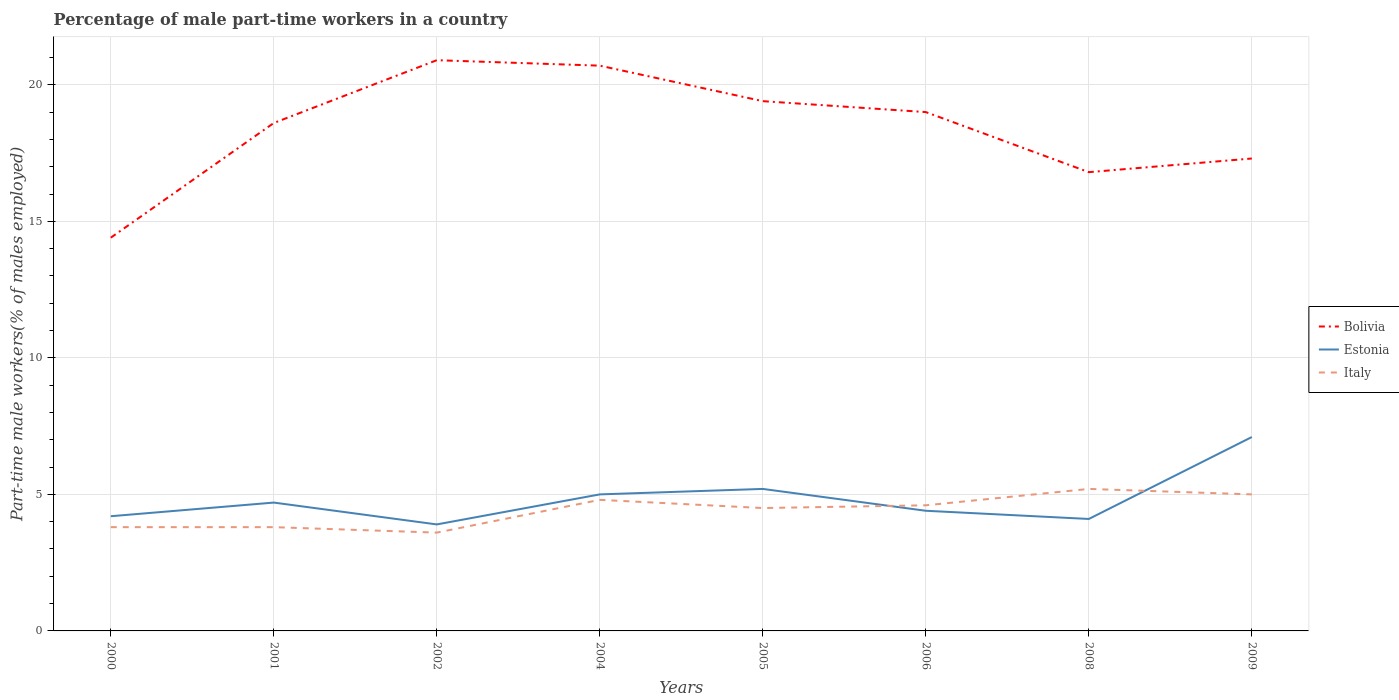How many different coloured lines are there?
Offer a very short reply. 3. Does the line corresponding to Italy intersect with the line corresponding to Bolivia?
Your answer should be very brief. No. Across all years, what is the maximum percentage of male part-time workers in Estonia?
Ensure brevity in your answer.  3.9. In which year was the percentage of male part-time workers in Italy maximum?
Give a very brief answer. 2002. What is the total percentage of male part-time workers in Estonia in the graph?
Keep it short and to the point. 0.6. What is the difference between the highest and the second highest percentage of male part-time workers in Italy?
Your response must be concise. 1.6. What is the difference between the highest and the lowest percentage of male part-time workers in Estonia?
Your response must be concise. 3. How many lines are there?
Offer a terse response. 3. How many years are there in the graph?
Your answer should be compact. 8. What is the difference between two consecutive major ticks on the Y-axis?
Provide a succinct answer. 5. Are the values on the major ticks of Y-axis written in scientific E-notation?
Offer a very short reply. No. Does the graph contain any zero values?
Provide a short and direct response. No. Where does the legend appear in the graph?
Make the answer very short. Center right. How many legend labels are there?
Offer a very short reply. 3. How are the legend labels stacked?
Offer a very short reply. Vertical. What is the title of the graph?
Make the answer very short. Percentage of male part-time workers in a country. What is the label or title of the X-axis?
Your answer should be very brief. Years. What is the label or title of the Y-axis?
Provide a short and direct response. Part-time male workers(% of males employed). What is the Part-time male workers(% of males employed) in Bolivia in 2000?
Give a very brief answer. 14.4. What is the Part-time male workers(% of males employed) in Estonia in 2000?
Provide a succinct answer. 4.2. What is the Part-time male workers(% of males employed) in Italy in 2000?
Give a very brief answer. 3.8. What is the Part-time male workers(% of males employed) of Bolivia in 2001?
Offer a terse response. 18.6. What is the Part-time male workers(% of males employed) in Estonia in 2001?
Your answer should be very brief. 4.7. What is the Part-time male workers(% of males employed) in Italy in 2001?
Make the answer very short. 3.8. What is the Part-time male workers(% of males employed) in Bolivia in 2002?
Make the answer very short. 20.9. What is the Part-time male workers(% of males employed) of Estonia in 2002?
Give a very brief answer. 3.9. What is the Part-time male workers(% of males employed) in Italy in 2002?
Make the answer very short. 3.6. What is the Part-time male workers(% of males employed) of Bolivia in 2004?
Offer a terse response. 20.7. What is the Part-time male workers(% of males employed) in Italy in 2004?
Your response must be concise. 4.8. What is the Part-time male workers(% of males employed) of Bolivia in 2005?
Offer a terse response. 19.4. What is the Part-time male workers(% of males employed) of Estonia in 2005?
Your response must be concise. 5.2. What is the Part-time male workers(% of males employed) in Italy in 2005?
Provide a short and direct response. 4.5. What is the Part-time male workers(% of males employed) in Estonia in 2006?
Give a very brief answer. 4.4. What is the Part-time male workers(% of males employed) in Italy in 2006?
Your answer should be compact. 4.6. What is the Part-time male workers(% of males employed) of Bolivia in 2008?
Give a very brief answer. 16.8. What is the Part-time male workers(% of males employed) of Estonia in 2008?
Your response must be concise. 4.1. What is the Part-time male workers(% of males employed) in Italy in 2008?
Keep it short and to the point. 5.2. What is the Part-time male workers(% of males employed) of Bolivia in 2009?
Keep it short and to the point. 17.3. What is the Part-time male workers(% of males employed) in Estonia in 2009?
Offer a very short reply. 7.1. What is the Part-time male workers(% of males employed) of Italy in 2009?
Your answer should be very brief. 5. Across all years, what is the maximum Part-time male workers(% of males employed) in Bolivia?
Provide a short and direct response. 20.9. Across all years, what is the maximum Part-time male workers(% of males employed) of Estonia?
Offer a terse response. 7.1. Across all years, what is the maximum Part-time male workers(% of males employed) of Italy?
Provide a succinct answer. 5.2. Across all years, what is the minimum Part-time male workers(% of males employed) of Bolivia?
Your response must be concise. 14.4. Across all years, what is the minimum Part-time male workers(% of males employed) in Estonia?
Your answer should be compact. 3.9. Across all years, what is the minimum Part-time male workers(% of males employed) in Italy?
Your answer should be very brief. 3.6. What is the total Part-time male workers(% of males employed) in Bolivia in the graph?
Ensure brevity in your answer.  147.1. What is the total Part-time male workers(% of males employed) of Estonia in the graph?
Give a very brief answer. 38.6. What is the total Part-time male workers(% of males employed) in Italy in the graph?
Keep it short and to the point. 35.3. What is the difference between the Part-time male workers(% of males employed) of Bolivia in 2000 and that in 2001?
Keep it short and to the point. -4.2. What is the difference between the Part-time male workers(% of males employed) in Estonia in 2000 and that in 2001?
Provide a short and direct response. -0.5. What is the difference between the Part-time male workers(% of males employed) in Italy in 2000 and that in 2001?
Your response must be concise. 0. What is the difference between the Part-time male workers(% of males employed) in Estonia in 2000 and that in 2002?
Offer a terse response. 0.3. What is the difference between the Part-time male workers(% of males employed) in Italy in 2000 and that in 2002?
Offer a very short reply. 0.2. What is the difference between the Part-time male workers(% of males employed) in Bolivia in 2000 and that in 2004?
Offer a very short reply. -6.3. What is the difference between the Part-time male workers(% of males employed) in Estonia in 2000 and that in 2004?
Ensure brevity in your answer.  -0.8. What is the difference between the Part-time male workers(% of males employed) in Italy in 2000 and that in 2004?
Offer a terse response. -1. What is the difference between the Part-time male workers(% of males employed) of Bolivia in 2000 and that in 2005?
Make the answer very short. -5. What is the difference between the Part-time male workers(% of males employed) in Bolivia in 2000 and that in 2006?
Give a very brief answer. -4.6. What is the difference between the Part-time male workers(% of males employed) in Estonia in 2000 and that in 2006?
Offer a terse response. -0.2. What is the difference between the Part-time male workers(% of males employed) of Italy in 2000 and that in 2006?
Your answer should be compact. -0.8. What is the difference between the Part-time male workers(% of males employed) of Estonia in 2000 and that in 2008?
Your answer should be very brief. 0.1. What is the difference between the Part-time male workers(% of males employed) of Italy in 2000 and that in 2008?
Keep it short and to the point. -1.4. What is the difference between the Part-time male workers(% of males employed) in Italy in 2000 and that in 2009?
Offer a very short reply. -1.2. What is the difference between the Part-time male workers(% of males employed) of Estonia in 2001 and that in 2002?
Make the answer very short. 0.8. What is the difference between the Part-time male workers(% of males employed) in Bolivia in 2001 and that in 2004?
Make the answer very short. -2.1. What is the difference between the Part-time male workers(% of males employed) in Estonia in 2001 and that in 2005?
Your response must be concise. -0.5. What is the difference between the Part-time male workers(% of males employed) of Italy in 2001 and that in 2005?
Ensure brevity in your answer.  -0.7. What is the difference between the Part-time male workers(% of males employed) in Estonia in 2001 and that in 2006?
Keep it short and to the point. 0.3. What is the difference between the Part-time male workers(% of males employed) of Italy in 2001 and that in 2006?
Offer a terse response. -0.8. What is the difference between the Part-time male workers(% of males employed) of Estonia in 2001 and that in 2008?
Keep it short and to the point. 0.6. What is the difference between the Part-time male workers(% of males employed) in Estonia in 2002 and that in 2004?
Ensure brevity in your answer.  -1.1. What is the difference between the Part-time male workers(% of males employed) in Italy in 2002 and that in 2004?
Provide a succinct answer. -1.2. What is the difference between the Part-time male workers(% of males employed) in Estonia in 2002 and that in 2005?
Offer a very short reply. -1.3. What is the difference between the Part-time male workers(% of males employed) of Italy in 2002 and that in 2005?
Your response must be concise. -0.9. What is the difference between the Part-time male workers(% of males employed) in Italy in 2002 and that in 2006?
Keep it short and to the point. -1. What is the difference between the Part-time male workers(% of males employed) of Bolivia in 2002 and that in 2008?
Give a very brief answer. 4.1. What is the difference between the Part-time male workers(% of males employed) of Estonia in 2002 and that in 2008?
Provide a short and direct response. -0.2. What is the difference between the Part-time male workers(% of males employed) of Italy in 2002 and that in 2008?
Provide a short and direct response. -1.6. What is the difference between the Part-time male workers(% of males employed) in Estonia in 2002 and that in 2009?
Your response must be concise. -3.2. What is the difference between the Part-time male workers(% of males employed) in Estonia in 2004 and that in 2005?
Your response must be concise. -0.2. What is the difference between the Part-time male workers(% of males employed) in Bolivia in 2004 and that in 2006?
Make the answer very short. 1.7. What is the difference between the Part-time male workers(% of males employed) of Estonia in 2004 and that in 2009?
Offer a terse response. -2.1. What is the difference between the Part-time male workers(% of males employed) in Estonia in 2005 and that in 2006?
Ensure brevity in your answer.  0.8. What is the difference between the Part-time male workers(% of males employed) in Italy in 2005 and that in 2006?
Give a very brief answer. -0.1. What is the difference between the Part-time male workers(% of males employed) of Italy in 2005 and that in 2009?
Offer a terse response. -0.5. What is the difference between the Part-time male workers(% of males employed) in Estonia in 2006 and that in 2008?
Your response must be concise. 0.3. What is the difference between the Part-time male workers(% of males employed) of Italy in 2006 and that in 2008?
Your response must be concise. -0.6. What is the difference between the Part-time male workers(% of males employed) of Bolivia in 2006 and that in 2009?
Offer a very short reply. 1.7. What is the difference between the Part-time male workers(% of males employed) of Italy in 2006 and that in 2009?
Provide a short and direct response. -0.4. What is the difference between the Part-time male workers(% of males employed) in Estonia in 2008 and that in 2009?
Your answer should be very brief. -3. What is the difference between the Part-time male workers(% of males employed) of Bolivia in 2000 and the Part-time male workers(% of males employed) of Estonia in 2001?
Provide a succinct answer. 9.7. What is the difference between the Part-time male workers(% of males employed) in Estonia in 2000 and the Part-time male workers(% of males employed) in Italy in 2001?
Make the answer very short. 0.4. What is the difference between the Part-time male workers(% of males employed) in Bolivia in 2000 and the Part-time male workers(% of males employed) in Estonia in 2002?
Offer a terse response. 10.5. What is the difference between the Part-time male workers(% of males employed) in Bolivia in 2000 and the Part-time male workers(% of males employed) in Italy in 2002?
Provide a short and direct response. 10.8. What is the difference between the Part-time male workers(% of males employed) of Estonia in 2000 and the Part-time male workers(% of males employed) of Italy in 2002?
Make the answer very short. 0.6. What is the difference between the Part-time male workers(% of males employed) in Bolivia in 2000 and the Part-time male workers(% of males employed) in Estonia in 2008?
Your response must be concise. 10.3. What is the difference between the Part-time male workers(% of males employed) of Estonia in 2000 and the Part-time male workers(% of males employed) of Italy in 2008?
Your answer should be very brief. -1. What is the difference between the Part-time male workers(% of males employed) in Bolivia in 2001 and the Part-time male workers(% of males employed) in Estonia in 2002?
Give a very brief answer. 14.7. What is the difference between the Part-time male workers(% of males employed) of Estonia in 2001 and the Part-time male workers(% of males employed) of Italy in 2002?
Ensure brevity in your answer.  1.1. What is the difference between the Part-time male workers(% of males employed) of Bolivia in 2001 and the Part-time male workers(% of males employed) of Estonia in 2004?
Your response must be concise. 13.6. What is the difference between the Part-time male workers(% of males employed) of Estonia in 2001 and the Part-time male workers(% of males employed) of Italy in 2004?
Your answer should be very brief. -0.1. What is the difference between the Part-time male workers(% of males employed) of Bolivia in 2001 and the Part-time male workers(% of males employed) of Estonia in 2005?
Your answer should be compact. 13.4. What is the difference between the Part-time male workers(% of males employed) of Bolivia in 2001 and the Part-time male workers(% of males employed) of Italy in 2005?
Keep it short and to the point. 14.1. What is the difference between the Part-time male workers(% of males employed) in Estonia in 2001 and the Part-time male workers(% of males employed) in Italy in 2005?
Your answer should be compact. 0.2. What is the difference between the Part-time male workers(% of males employed) of Estonia in 2001 and the Part-time male workers(% of males employed) of Italy in 2006?
Give a very brief answer. 0.1. What is the difference between the Part-time male workers(% of males employed) in Bolivia in 2001 and the Part-time male workers(% of males employed) in Italy in 2008?
Your response must be concise. 13.4. What is the difference between the Part-time male workers(% of males employed) of Estonia in 2001 and the Part-time male workers(% of males employed) of Italy in 2008?
Give a very brief answer. -0.5. What is the difference between the Part-time male workers(% of males employed) in Bolivia in 2002 and the Part-time male workers(% of males employed) in Estonia in 2004?
Your answer should be very brief. 15.9. What is the difference between the Part-time male workers(% of males employed) of Estonia in 2002 and the Part-time male workers(% of males employed) of Italy in 2005?
Offer a very short reply. -0.6. What is the difference between the Part-time male workers(% of males employed) in Bolivia in 2002 and the Part-time male workers(% of males employed) in Italy in 2006?
Offer a very short reply. 16.3. What is the difference between the Part-time male workers(% of males employed) in Estonia in 2002 and the Part-time male workers(% of males employed) in Italy in 2006?
Make the answer very short. -0.7. What is the difference between the Part-time male workers(% of males employed) of Bolivia in 2002 and the Part-time male workers(% of males employed) of Estonia in 2008?
Offer a terse response. 16.8. What is the difference between the Part-time male workers(% of males employed) in Bolivia in 2002 and the Part-time male workers(% of males employed) in Italy in 2008?
Provide a short and direct response. 15.7. What is the difference between the Part-time male workers(% of males employed) of Estonia in 2002 and the Part-time male workers(% of males employed) of Italy in 2008?
Make the answer very short. -1.3. What is the difference between the Part-time male workers(% of males employed) of Bolivia in 2002 and the Part-time male workers(% of males employed) of Estonia in 2009?
Provide a short and direct response. 13.8. What is the difference between the Part-time male workers(% of males employed) in Estonia in 2002 and the Part-time male workers(% of males employed) in Italy in 2009?
Give a very brief answer. -1.1. What is the difference between the Part-time male workers(% of males employed) in Bolivia in 2004 and the Part-time male workers(% of males employed) in Estonia in 2005?
Ensure brevity in your answer.  15.5. What is the difference between the Part-time male workers(% of males employed) of Bolivia in 2004 and the Part-time male workers(% of males employed) of Italy in 2005?
Make the answer very short. 16.2. What is the difference between the Part-time male workers(% of males employed) of Estonia in 2004 and the Part-time male workers(% of males employed) of Italy in 2005?
Give a very brief answer. 0.5. What is the difference between the Part-time male workers(% of males employed) of Bolivia in 2004 and the Part-time male workers(% of males employed) of Estonia in 2006?
Your response must be concise. 16.3. What is the difference between the Part-time male workers(% of males employed) in Bolivia in 2004 and the Part-time male workers(% of males employed) in Italy in 2006?
Your response must be concise. 16.1. What is the difference between the Part-time male workers(% of males employed) of Estonia in 2004 and the Part-time male workers(% of males employed) of Italy in 2008?
Keep it short and to the point. -0.2. What is the difference between the Part-time male workers(% of males employed) of Bolivia in 2004 and the Part-time male workers(% of males employed) of Estonia in 2009?
Make the answer very short. 13.6. What is the difference between the Part-time male workers(% of males employed) in Bolivia in 2004 and the Part-time male workers(% of males employed) in Italy in 2009?
Keep it short and to the point. 15.7. What is the difference between the Part-time male workers(% of males employed) of Bolivia in 2005 and the Part-time male workers(% of males employed) of Italy in 2006?
Your answer should be compact. 14.8. What is the difference between the Part-time male workers(% of males employed) of Bolivia in 2005 and the Part-time male workers(% of males employed) of Estonia in 2008?
Offer a very short reply. 15.3. What is the difference between the Part-time male workers(% of males employed) in Estonia in 2005 and the Part-time male workers(% of males employed) in Italy in 2008?
Ensure brevity in your answer.  0. What is the difference between the Part-time male workers(% of males employed) of Bolivia in 2005 and the Part-time male workers(% of males employed) of Estonia in 2009?
Your response must be concise. 12.3. What is the difference between the Part-time male workers(% of males employed) of Estonia in 2005 and the Part-time male workers(% of males employed) of Italy in 2009?
Ensure brevity in your answer.  0.2. What is the difference between the Part-time male workers(% of males employed) in Bolivia in 2006 and the Part-time male workers(% of males employed) in Estonia in 2008?
Your answer should be very brief. 14.9. What is the difference between the Part-time male workers(% of males employed) in Bolivia in 2006 and the Part-time male workers(% of males employed) in Italy in 2008?
Your answer should be compact. 13.8. What is the difference between the Part-time male workers(% of males employed) of Estonia in 2006 and the Part-time male workers(% of males employed) of Italy in 2008?
Keep it short and to the point. -0.8. What is the difference between the Part-time male workers(% of males employed) of Bolivia in 2006 and the Part-time male workers(% of males employed) of Italy in 2009?
Give a very brief answer. 14. What is the difference between the Part-time male workers(% of males employed) of Estonia in 2006 and the Part-time male workers(% of males employed) of Italy in 2009?
Your answer should be very brief. -0.6. What is the average Part-time male workers(% of males employed) of Bolivia per year?
Offer a terse response. 18.39. What is the average Part-time male workers(% of males employed) of Estonia per year?
Provide a short and direct response. 4.83. What is the average Part-time male workers(% of males employed) of Italy per year?
Your answer should be compact. 4.41. In the year 2000, what is the difference between the Part-time male workers(% of males employed) in Bolivia and Part-time male workers(% of males employed) in Italy?
Give a very brief answer. 10.6. In the year 2001, what is the difference between the Part-time male workers(% of males employed) of Bolivia and Part-time male workers(% of males employed) of Estonia?
Give a very brief answer. 13.9. In the year 2001, what is the difference between the Part-time male workers(% of males employed) of Estonia and Part-time male workers(% of males employed) of Italy?
Your answer should be very brief. 0.9. In the year 2002, what is the difference between the Part-time male workers(% of males employed) in Estonia and Part-time male workers(% of males employed) in Italy?
Provide a succinct answer. 0.3. In the year 2004, what is the difference between the Part-time male workers(% of males employed) in Bolivia and Part-time male workers(% of males employed) in Italy?
Keep it short and to the point. 15.9. In the year 2004, what is the difference between the Part-time male workers(% of males employed) of Estonia and Part-time male workers(% of males employed) of Italy?
Your answer should be very brief. 0.2. In the year 2006, what is the difference between the Part-time male workers(% of males employed) in Bolivia and Part-time male workers(% of males employed) in Estonia?
Provide a short and direct response. 14.6. In the year 2006, what is the difference between the Part-time male workers(% of males employed) in Bolivia and Part-time male workers(% of males employed) in Italy?
Your response must be concise. 14.4. In the year 2008, what is the difference between the Part-time male workers(% of males employed) of Estonia and Part-time male workers(% of males employed) of Italy?
Provide a succinct answer. -1.1. In the year 2009, what is the difference between the Part-time male workers(% of males employed) in Bolivia and Part-time male workers(% of males employed) in Estonia?
Provide a succinct answer. 10.2. In the year 2009, what is the difference between the Part-time male workers(% of males employed) in Bolivia and Part-time male workers(% of males employed) in Italy?
Offer a terse response. 12.3. In the year 2009, what is the difference between the Part-time male workers(% of males employed) in Estonia and Part-time male workers(% of males employed) in Italy?
Your answer should be compact. 2.1. What is the ratio of the Part-time male workers(% of males employed) of Bolivia in 2000 to that in 2001?
Provide a short and direct response. 0.77. What is the ratio of the Part-time male workers(% of males employed) of Estonia in 2000 to that in 2001?
Offer a terse response. 0.89. What is the ratio of the Part-time male workers(% of males employed) of Bolivia in 2000 to that in 2002?
Give a very brief answer. 0.69. What is the ratio of the Part-time male workers(% of males employed) in Italy in 2000 to that in 2002?
Give a very brief answer. 1.06. What is the ratio of the Part-time male workers(% of males employed) in Bolivia in 2000 to that in 2004?
Make the answer very short. 0.7. What is the ratio of the Part-time male workers(% of males employed) of Estonia in 2000 to that in 2004?
Provide a short and direct response. 0.84. What is the ratio of the Part-time male workers(% of males employed) in Italy in 2000 to that in 2004?
Offer a terse response. 0.79. What is the ratio of the Part-time male workers(% of males employed) in Bolivia in 2000 to that in 2005?
Give a very brief answer. 0.74. What is the ratio of the Part-time male workers(% of males employed) in Estonia in 2000 to that in 2005?
Give a very brief answer. 0.81. What is the ratio of the Part-time male workers(% of males employed) of Italy in 2000 to that in 2005?
Give a very brief answer. 0.84. What is the ratio of the Part-time male workers(% of males employed) of Bolivia in 2000 to that in 2006?
Offer a terse response. 0.76. What is the ratio of the Part-time male workers(% of males employed) of Estonia in 2000 to that in 2006?
Ensure brevity in your answer.  0.95. What is the ratio of the Part-time male workers(% of males employed) of Italy in 2000 to that in 2006?
Your answer should be very brief. 0.83. What is the ratio of the Part-time male workers(% of males employed) in Estonia in 2000 to that in 2008?
Ensure brevity in your answer.  1.02. What is the ratio of the Part-time male workers(% of males employed) in Italy in 2000 to that in 2008?
Give a very brief answer. 0.73. What is the ratio of the Part-time male workers(% of males employed) in Bolivia in 2000 to that in 2009?
Your answer should be very brief. 0.83. What is the ratio of the Part-time male workers(% of males employed) of Estonia in 2000 to that in 2009?
Your answer should be very brief. 0.59. What is the ratio of the Part-time male workers(% of males employed) of Italy in 2000 to that in 2009?
Provide a succinct answer. 0.76. What is the ratio of the Part-time male workers(% of males employed) in Bolivia in 2001 to that in 2002?
Make the answer very short. 0.89. What is the ratio of the Part-time male workers(% of males employed) of Estonia in 2001 to that in 2002?
Offer a very short reply. 1.21. What is the ratio of the Part-time male workers(% of males employed) of Italy in 2001 to that in 2002?
Ensure brevity in your answer.  1.06. What is the ratio of the Part-time male workers(% of males employed) in Bolivia in 2001 to that in 2004?
Keep it short and to the point. 0.9. What is the ratio of the Part-time male workers(% of males employed) in Estonia in 2001 to that in 2004?
Offer a very short reply. 0.94. What is the ratio of the Part-time male workers(% of males employed) in Italy in 2001 to that in 2004?
Provide a succinct answer. 0.79. What is the ratio of the Part-time male workers(% of males employed) in Bolivia in 2001 to that in 2005?
Offer a terse response. 0.96. What is the ratio of the Part-time male workers(% of males employed) of Estonia in 2001 to that in 2005?
Ensure brevity in your answer.  0.9. What is the ratio of the Part-time male workers(% of males employed) of Italy in 2001 to that in 2005?
Keep it short and to the point. 0.84. What is the ratio of the Part-time male workers(% of males employed) in Bolivia in 2001 to that in 2006?
Make the answer very short. 0.98. What is the ratio of the Part-time male workers(% of males employed) in Estonia in 2001 to that in 2006?
Ensure brevity in your answer.  1.07. What is the ratio of the Part-time male workers(% of males employed) in Italy in 2001 to that in 2006?
Keep it short and to the point. 0.83. What is the ratio of the Part-time male workers(% of males employed) of Bolivia in 2001 to that in 2008?
Provide a succinct answer. 1.11. What is the ratio of the Part-time male workers(% of males employed) in Estonia in 2001 to that in 2008?
Provide a succinct answer. 1.15. What is the ratio of the Part-time male workers(% of males employed) of Italy in 2001 to that in 2008?
Your response must be concise. 0.73. What is the ratio of the Part-time male workers(% of males employed) of Bolivia in 2001 to that in 2009?
Your response must be concise. 1.08. What is the ratio of the Part-time male workers(% of males employed) of Estonia in 2001 to that in 2009?
Provide a short and direct response. 0.66. What is the ratio of the Part-time male workers(% of males employed) in Italy in 2001 to that in 2009?
Ensure brevity in your answer.  0.76. What is the ratio of the Part-time male workers(% of males employed) in Bolivia in 2002 to that in 2004?
Offer a terse response. 1.01. What is the ratio of the Part-time male workers(% of males employed) in Estonia in 2002 to that in 2004?
Provide a short and direct response. 0.78. What is the ratio of the Part-time male workers(% of males employed) in Italy in 2002 to that in 2004?
Give a very brief answer. 0.75. What is the ratio of the Part-time male workers(% of males employed) in Bolivia in 2002 to that in 2005?
Ensure brevity in your answer.  1.08. What is the ratio of the Part-time male workers(% of males employed) in Estonia in 2002 to that in 2005?
Keep it short and to the point. 0.75. What is the ratio of the Part-time male workers(% of males employed) in Estonia in 2002 to that in 2006?
Ensure brevity in your answer.  0.89. What is the ratio of the Part-time male workers(% of males employed) of Italy in 2002 to that in 2006?
Provide a short and direct response. 0.78. What is the ratio of the Part-time male workers(% of males employed) of Bolivia in 2002 to that in 2008?
Provide a short and direct response. 1.24. What is the ratio of the Part-time male workers(% of males employed) of Estonia in 2002 to that in 2008?
Offer a terse response. 0.95. What is the ratio of the Part-time male workers(% of males employed) of Italy in 2002 to that in 2008?
Provide a succinct answer. 0.69. What is the ratio of the Part-time male workers(% of males employed) of Bolivia in 2002 to that in 2009?
Make the answer very short. 1.21. What is the ratio of the Part-time male workers(% of males employed) in Estonia in 2002 to that in 2009?
Your response must be concise. 0.55. What is the ratio of the Part-time male workers(% of males employed) in Italy in 2002 to that in 2009?
Your response must be concise. 0.72. What is the ratio of the Part-time male workers(% of males employed) in Bolivia in 2004 to that in 2005?
Your answer should be very brief. 1.07. What is the ratio of the Part-time male workers(% of males employed) of Estonia in 2004 to that in 2005?
Offer a terse response. 0.96. What is the ratio of the Part-time male workers(% of males employed) of Italy in 2004 to that in 2005?
Your answer should be very brief. 1.07. What is the ratio of the Part-time male workers(% of males employed) of Bolivia in 2004 to that in 2006?
Give a very brief answer. 1.09. What is the ratio of the Part-time male workers(% of males employed) in Estonia in 2004 to that in 2006?
Ensure brevity in your answer.  1.14. What is the ratio of the Part-time male workers(% of males employed) of Italy in 2004 to that in 2006?
Your answer should be very brief. 1.04. What is the ratio of the Part-time male workers(% of males employed) of Bolivia in 2004 to that in 2008?
Keep it short and to the point. 1.23. What is the ratio of the Part-time male workers(% of males employed) in Estonia in 2004 to that in 2008?
Give a very brief answer. 1.22. What is the ratio of the Part-time male workers(% of males employed) of Bolivia in 2004 to that in 2009?
Your answer should be compact. 1.2. What is the ratio of the Part-time male workers(% of males employed) of Estonia in 2004 to that in 2009?
Your response must be concise. 0.7. What is the ratio of the Part-time male workers(% of males employed) of Italy in 2004 to that in 2009?
Offer a very short reply. 0.96. What is the ratio of the Part-time male workers(% of males employed) of Bolivia in 2005 to that in 2006?
Ensure brevity in your answer.  1.02. What is the ratio of the Part-time male workers(% of males employed) of Estonia in 2005 to that in 2006?
Keep it short and to the point. 1.18. What is the ratio of the Part-time male workers(% of males employed) in Italy in 2005 to that in 2006?
Ensure brevity in your answer.  0.98. What is the ratio of the Part-time male workers(% of males employed) in Bolivia in 2005 to that in 2008?
Keep it short and to the point. 1.15. What is the ratio of the Part-time male workers(% of males employed) of Estonia in 2005 to that in 2008?
Your response must be concise. 1.27. What is the ratio of the Part-time male workers(% of males employed) in Italy in 2005 to that in 2008?
Your response must be concise. 0.87. What is the ratio of the Part-time male workers(% of males employed) of Bolivia in 2005 to that in 2009?
Your answer should be very brief. 1.12. What is the ratio of the Part-time male workers(% of males employed) in Estonia in 2005 to that in 2009?
Keep it short and to the point. 0.73. What is the ratio of the Part-time male workers(% of males employed) in Bolivia in 2006 to that in 2008?
Keep it short and to the point. 1.13. What is the ratio of the Part-time male workers(% of males employed) of Estonia in 2006 to that in 2008?
Keep it short and to the point. 1.07. What is the ratio of the Part-time male workers(% of males employed) of Italy in 2006 to that in 2008?
Your response must be concise. 0.88. What is the ratio of the Part-time male workers(% of males employed) in Bolivia in 2006 to that in 2009?
Keep it short and to the point. 1.1. What is the ratio of the Part-time male workers(% of males employed) of Estonia in 2006 to that in 2009?
Give a very brief answer. 0.62. What is the ratio of the Part-time male workers(% of males employed) of Bolivia in 2008 to that in 2009?
Provide a short and direct response. 0.97. What is the ratio of the Part-time male workers(% of males employed) of Estonia in 2008 to that in 2009?
Your answer should be compact. 0.58. What is the difference between the highest and the second highest Part-time male workers(% of males employed) of Italy?
Offer a very short reply. 0.2. What is the difference between the highest and the lowest Part-time male workers(% of males employed) of Bolivia?
Your answer should be very brief. 6.5. What is the difference between the highest and the lowest Part-time male workers(% of males employed) of Estonia?
Keep it short and to the point. 3.2. What is the difference between the highest and the lowest Part-time male workers(% of males employed) in Italy?
Provide a short and direct response. 1.6. 